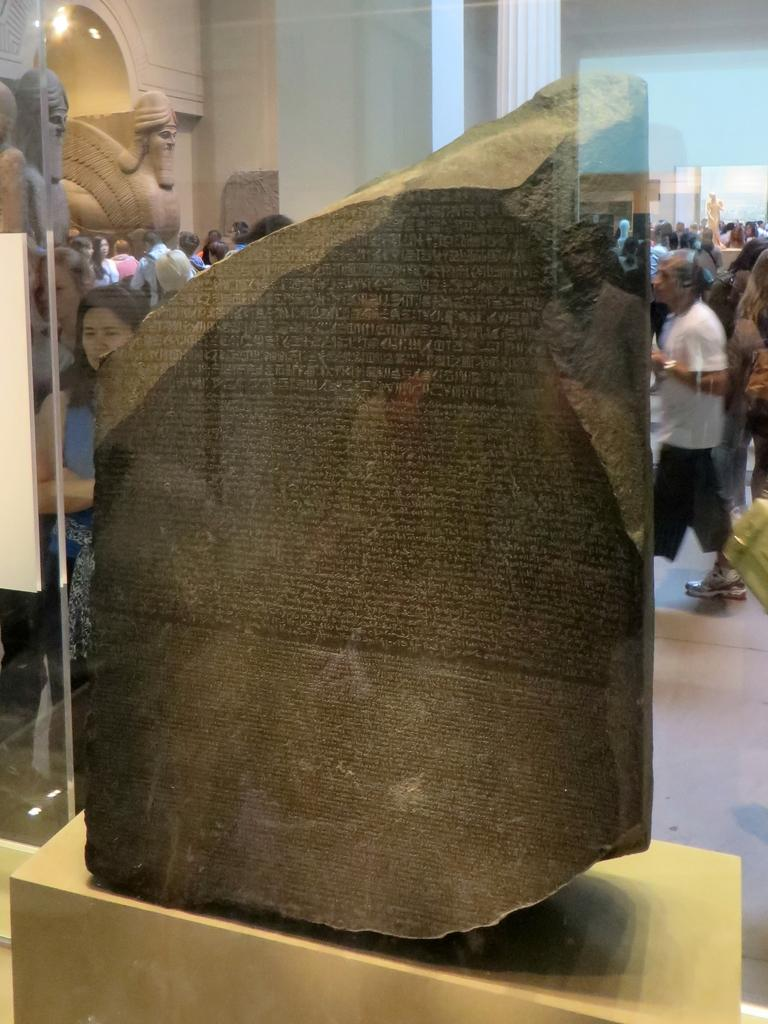What is the main object in the image? There is a stone in the image. What other objects can be seen in the image? There are sculptures and a group of people on the floor in the image. What is visible in the background of the image? There is a statue visible in the background of the image. Can you see any waves in the image? There are no waves present in the image. 